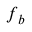<formula> <loc_0><loc_0><loc_500><loc_500>f _ { b }</formula> 